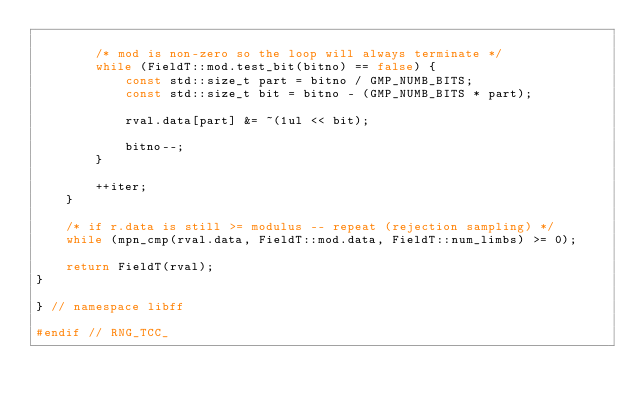<code> <loc_0><loc_0><loc_500><loc_500><_C++_>
        /* mod is non-zero so the loop will always terminate */
        while (FieldT::mod.test_bit(bitno) == false) {
            const std::size_t part = bitno / GMP_NUMB_BITS;
            const std::size_t bit = bitno - (GMP_NUMB_BITS * part);

            rval.data[part] &= ~(1ul << bit);

            bitno--;
        }

        ++iter;
    }

    /* if r.data is still >= modulus -- repeat (rejection sampling) */
    while (mpn_cmp(rval.data, FieldT::mod.data, FieldT::num_limbs) >= 0);

    return FieldT(rval);
}

} // namespace libff

#endif // RNG_TCC_
</code> 